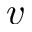<formula> <loc_0><loc_0><loc_500><loc_500>v</formula> 